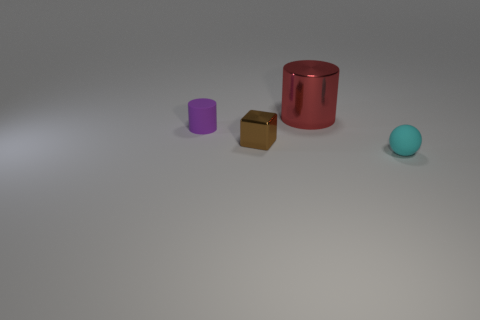Add 3 blue cubes. How many objects exist? 7 Subtract all balls. How many objects are left? 3 Subtract 0 green cubes. How many objects are left? 4 Subtract all large cylinders. Subtract all small red metal things. How many objects are left? 3 Add 2 brown metal cubes. How many brown metal cubes are left? 3 Add 3 big objects. How many big objects exist? 4 